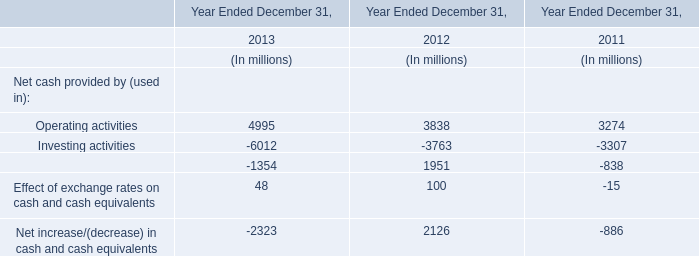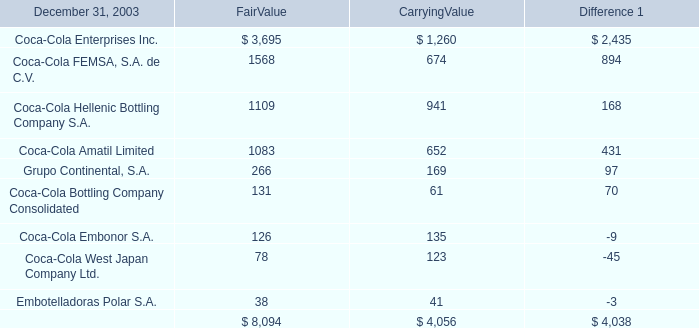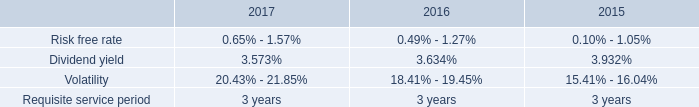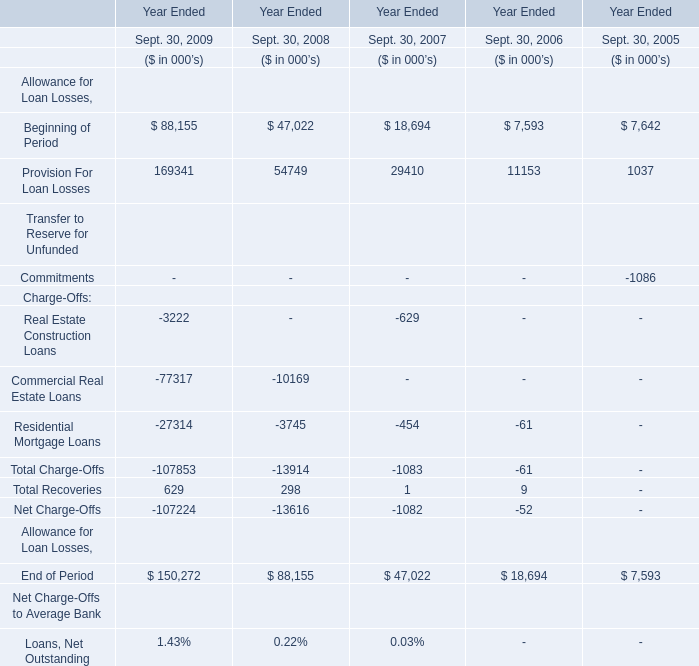What is the sum of Beginning of Period, Provision For Loan Losses and Real Estate Construction Loans in 2009? (in thousand) 
Computations: ((88155 + 169341) - 3222)
Answer: 254274.0. 